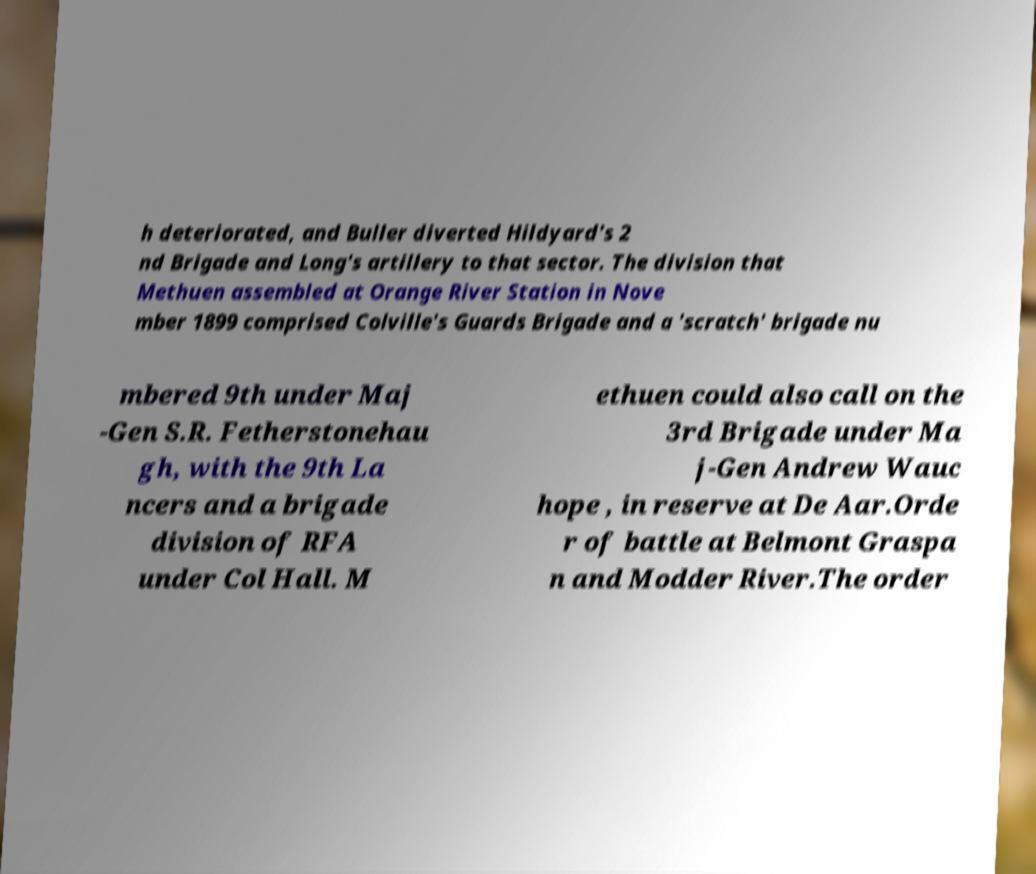Can you read and provide the text displayed in the image?This photo seems to have some interesting text. Can you extract and type it out for me? h deteriorated, and Buller diverted Hildyard's 2 nd Brigade and Long's artillery to that sector. The division that Methuen assembled at Orange River Station in Nove mber 1899 comprised Colville's Guards Brigade and a 'scratch' brigade nu mbered 9th under Maj -Gen S.R. Fetherstonehau gh, with the 9th La ncers and a brigade division of RFA under Col Hall. M ethuen could also call on the 3rd Brigade under Ma j-Gen Andrew Wauc hope , in reserve at De Aar.Orde r of battle at Belmont Graspa n and Modder River.The order 